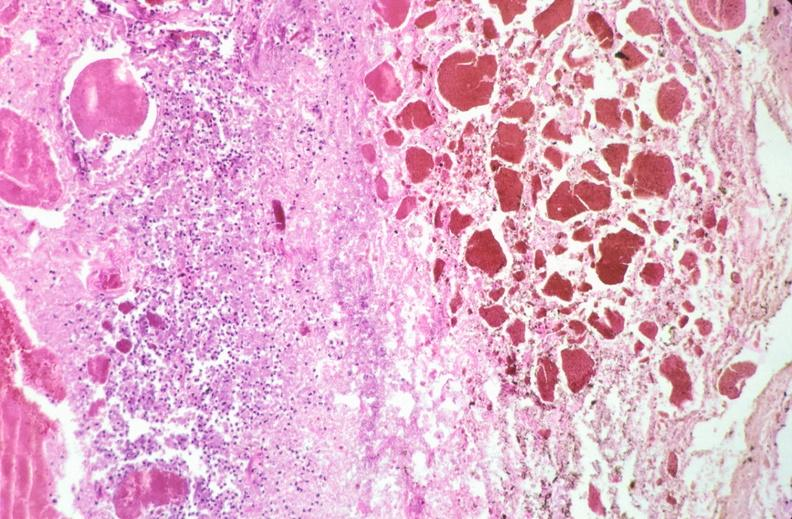does hemorrhage newborn show stomach, necrotizing esophagitis and gastritis, sulfuric acid ingested as suicide attempt?
Answer the question using a single word or phrase. No 